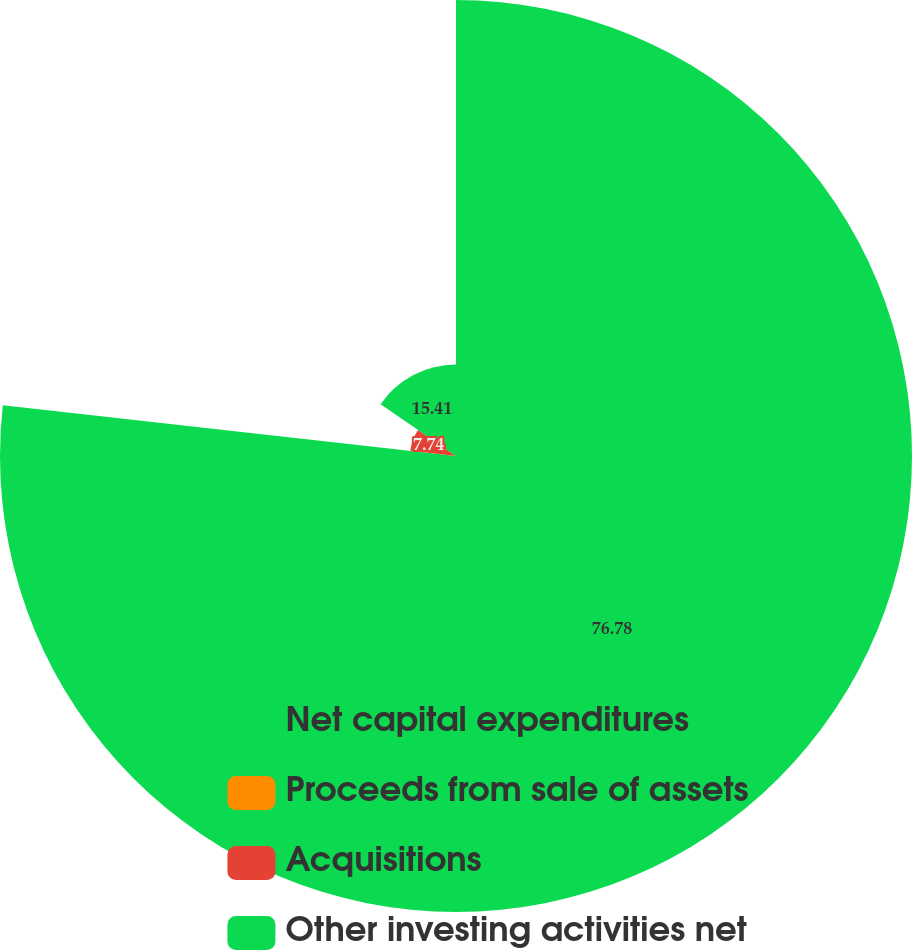<chart> <loc_0><loc_0><loc_500><loc_500><pie_chart><fcel>Net capital expenditures<fcel>Proceeds from sale of assets<fcel>Acquisitions<fcel>Other investing activities net<nl><fcel>76.77%<fcel>0.07%<fcel>7.74%<fcel>15.41%<nl></chart> 